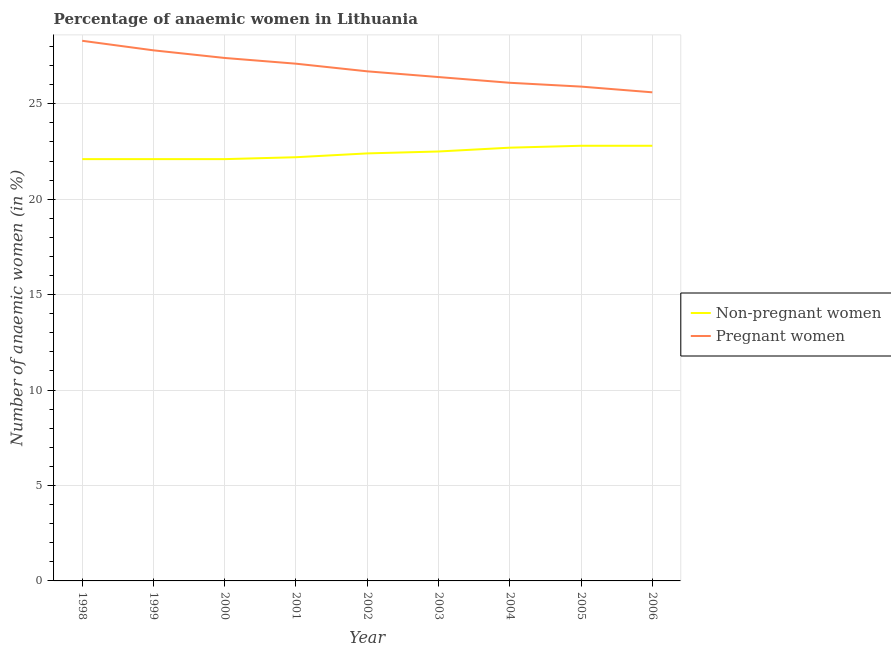How many different coloured lines are there?
Keep it short and to the point. 2. Is the number of lines equal to the number of legend labels?
Give a very brief answer. Yes. What is the percentage of non-pregnant anaemic women in 2002?
Provide a succinct answer. 22.4. Across all years, what is the maximum percentage of non-pregnant anaemic women?
Your response must be concise. 22.8. Across all years, what is the minimum percentage of pregnant anaemic women?
Your answer should be very brief. 25.6. In which year was the percentage of pregnant anaemic women maximum?
Your response must be concise. 1998. What is the total percentage of pregnant anaemic women in the graph?
Keep it short and to the point. 241.3. What is the difference between the percentage of pregnant anaemic women in 2003 and that in 2005?
Offer a very short reply. 0.5. What is the difference between the percentage of pregnant anaemic women in 2002 and the percentage of non-pregnant anaemic women in 2001?
Ensure brevity in your answer.  4.5. What is the average percentage of pregnant anaemic women per year?
Your answer should be very brief. 26.81. In the year 2003, what is the difference between the percentage of pregnant anaemic women and percentage of non-pregnant anaemic women?
Make the answer very short. 3.9. What is the ratio of the percentage of non-pregnant anaemic women in 1998 to that in 2002?
Your answer should be very brief. 0.99. Is the difference between the percentage of pregnant anaemic women in 1999 and 2005 greater than the difference between the percentage of non-pregnant anaemic women in 1999 and 2005?
Provide a short and direct response. Yes. What is the difference between the highest and the second highest percentage of pregnant anaemic women?
Your answer should be very brief. 0.5. What is the difference between the highest and the lowest percentage of non-pregnant anaemic women?
Ensure brevity in your answer.  0.7. Is the percentage of pregnant anaemic women strictly greater than the percentage of non-pregnant anaemic women over the years?
Make the answer very short. Yes. Is the percentage of non-pregnant anaemic women strictly less than the percentage of pregnant anaemic women over the years?
Offer a terse response. Yes. How many years are there in the graph?
Offer a very short reply. 9. Does the graph contain any zero values?
Keep it short and to the point. No. Does the graph contain grids?
Ensure brevity in your answer.  Yes. How are the legend labels stacked?
Provide a succinct answer. Vertical. What is the title of the graph?
Your response must be concise. Percentage of anaemic women in Lithuania. Does "US$" appear as one of the legend labels in the graph?
Provide a short and direct response. No. What is the label or title of the X-axis?
Give a very brief answer. Year. What is the label or title of the Y-axis?
Ensure brevity in your answer.  Number of anaemic women (in %). What is the Number of anaemic women (in %) in Non-pregnant women in 1998?
Offer a very short reply. 22.1. What is the Number of anaemic women (in %) of Pregnant women in 1998?
Keep it short and to the point. 28.3. What is the Number of anaemic women (in %) of Non-pregnant women in 1999?
Provide a short and direct response. 22.1. What is the Number of anaemic women (in %) in Pregnant women in 1999?
Provide a short and direct response. 27.8. What is the Number of anaemic women (in %) of Non-pregnant women in 2000?
Offer a terse response. 22.1. What is the Number of anaemic women (in %) in Pregnant women in 2000?
Provide a short and direct response. 27.4. What is the Number of anaemic women (in %) in Pregnant women in 2001?
Offer a very short reply. 27.1. What is the Number of anaemic women (in %) of Non-pregnant women in 2002?
Ensure brevity in your answer.  22.4. What is the Number of anaemic women (in %) in Pregnant women in 2002?
Your response must be concise. 26.7. What is the Number of anaemic women (in %) in Non-pregnant women in 2003?
Give a very brief answer. 22.5. What is the Number of anaemic women (in %) of Pregnant women in 2003?
Ensure brevity in your answer.  26.4. What is the Number of anaemic women (in %) in Non-pregnant women in 2004?
Your answer should be very brief. 22.7. What is the Number of anaemic women (in %) of Pregnant women in 2004?
Provide a succinct answer. 26.1. What is the Number of anaemic women (in %) in Non-pregnant women in 2005?
Provide a succinct answer. 22.8. What is the Number of anaemic women (in %) in Pregnant women in 2005?
Your answer should be very brief. 25.9. What is the Number of anaemic women (in %) of Non-pregnant women in 2006?
Your answer should be compact. 22.8. What is the Number of anaemic women (in %) in Pregnant women in 2006?
Keep it short and to the point. 25.6. Across all years, what is the maximum Number of anaemic women (in %) in Non-pregnant women?
Offer a very short reply. 22.8. Across all years, what is the maximum Number of anaemic women (in %) in Pregnant women?
Your answer should be very brief. 28.3. Across all years, what is the minimum Number of anaemic women (in %) in Non-pregnant women?
Keep it short and to the point. 22.1. Across all years, what is the minimum Number of anaemic women (in %) in Pregnant women?
Offer a terse response. 25.6. What is the total Number of anaemic women (in %) in Non-pregnant women in the graph?
Ensure brevity in your answer.  201.7. What is the total Number of anaemic women (in %) in Pregnant women in the graph?
Ensure brevity in your answer.  241.3. What is the difference between the Number of anaemic women (in %) in Non-pregnant women in 1998 and that in 2001?
Offer a very short reply. -0.1. What is the difference between the Number of anaemic women (in %) in Non-pregnant women in 1998 and that in 2002?
Your response must be concise. -0.3. What is the difference between the Number of anaemic women (in %) in Non-pregnant women in 1998 and that in 2003?
Keep it short and to the point. -0.4. What is the difference between the Number of anaemic women (in %) of Pregnant women in 1998 and that in 2003?
Offer a terse response. 1.9. What is the difference between the Number of anaemic women (in %) in Non-pregnant women in 1998 and that in 2004?
Offer a terse response. -0.6. What is the difference between the Number of anaemic women (in %) of Pregnant women in 1998 and that in 2004?
Your response must be concise. 2.2. What is the difference between the Number of anaemic women (in %) of Non-pregnant women in 1998 and that in 2005?
Make the answer very short. -0.7. What is the difference between the Number of anaemic women (in %) of Pregnant women in 1999 and that in 2000?
Your response must be concise. 0.4. What is the difference between the Number of anaemic women (in %) in Non-pregnant women in 1999 and that in 2001?
Give a very brief answer. -0.1. What is the difference between the Number of anaemic women (in %) in Non-pregnant women in 1999 and that in 2002?
Offer a very short reply. -0.3. What is the difference between the Number of anaemic women (in %) in Pregnant women in 1999 and that in 2004?
Your answer should be compact. 1.7. What is the difference between the Number of anaemic women (in %) of Pregnant women in 1999 and that in 2005?
Offer a terse response. 1.9. What is the difference between the Number of anaemic women (in %) of Pregnant women in 1999 and that in 2006?
Your response must be concise. 2.2. What is the difference between the Number of anaemic women (in %) of Non-pregnant women in 2000 and that in 2001?
Make the answer very short. -0.1. What is the difference between the Number of anaemic women (in %) in Non-pregnant women in 2000 and that in 2003?
Offer a very short reply. -0.4. What is the difference between the Number of anaemic women (in %) in Pregnant women in 2000 and that in 2003?
Offer a very short reply. 1. What is the difference between the Number of anaemic women (in %) of Pregnant women in 2000 and that in 2004?
Give a very brief answer. 1.3. What is the difference between the Number of anaemic women (in %) in Non-pregnant women in 2000 and that in 2005?
Keep it short and to the point. -0.7. What is the difference between the Number of anaemic women (in %) in Pregnant women in 2000 and that in 2006?
Your response must be concise. 1.8. What is the difference between the Number of anaemic women (in %) in Non-pregnant women in 2001 and that in 2002?
Provide a succinct answer. -0.2. What is the difference between the Number of anaemic women (in %) of Non-pregnant women in 2001 and that in 2003?
Provide a succinct answer. -0.3. What is the difference between the Number of anaemic women (in %) of Pregnant women in 2001 and that in 2003?
Ensure brevity in your answer.  0.7. What is the difference between the Number of anaemic women (in %) in Pregnant women in 2001 and that in 2004?
Offer a very short reply. 1. What is the difference between the Number of anaemic women (in %) in Pregnant women in 2001 and that in 2005?
Offer a very short reply. 1.2. What is the difference between the Number of anaemic women (in %) of Pregnant women in 2002 and that in 2003?
Provide a short and direct response. 0.3. What is the difference between the Number of anaemic women (in %) of Non-pregnant women in 2003 and that in 2006?
Give a very brief answer. -0.3. What is the difference between the Number of anaemic women (in %) of Pregnant women in 2003 and that in 2006?
Provide a succinct answer. 0.8. What is the difference between the Number of anaemic women (in %) in Non-pregnant women in 2004 and that in 2006?
Your answer should be compact. -0.1. What is the difference between the Number of anaemic women (in %) in Non-pregnant women in 2005 and that in 2006?
Your response must be concise. 0. What is the difference between the Number of anaemic women (in %) in Pregnant women in 2005 and that in 2006?
Offer a very short reply. 0.3. What is the difference between the Number of anaemic women (in %) in Non-pregnant women in 1998 and the Number of anaemic women (in %) in Pregnant women in 1999?
Ensure brevity in your answer.  -5.7. What is the difference between the Number of anaemic women (in %) of Non-pregnant women in 1998 and the Number of anaemic women (in %) of Pregnant women in 2001?
Provide a short and direct response. -5. What is the difference between the Number of anaemic women (in %) in Non-pregnant women in 1998 and the Number of anaemic women (in %) in Pregnant women in 2002?
Your answer should be very brief. -4.6. What is the difference between the Number of anaemic women (in %) of Non-pregnant women in 1998 and the Number of anaemic women (in %) of Pregnant women in 2003?
Make the answer very short. -4.3. What is the difference between the Number of anaemic women (in %) in Non-pregnant women in 1998 and the Number of anaemic women (in %) in Pregnant women in 2004?
Give a very brief answer. -4. What is the difference between the Number of anaemic women (in %) of Non-pregnant women in 1998 and the Number of anaemic women (in %) of Pregnant women in 2005?
Your answer should be compact. -3.8. What is the difference between the Number of anaemic women (in %) of Non-pregnant women in 1999 and the Number of anaemic women (in %) of Pregnant women in 2005?
Make the answer very short. -3.8. What is the difference between the Number of anaemic women (in %) in Non-pregnant women in 2000 and the Number of anaemic women (in %) in Pregnant women in 2001?
Offer a very short reply. -5. What is the difference between the Number of anaemic women (in %) in Non-pregnant women in 2000 and the Number of anaemic women (in %) in Pregnant women in 2002?
Your answer should be very brief. -4.6. What is the difference between the Number of anaemic women (in %) in Non-pregnant women in 2000 and the Number of anaemic women (in %) in Pregnant women in 2003?
Keep it short and to the point. -4.3. What is the difference between the Number of anaemic women (in %) of Non-pregnant women in 2000 and the Number of anaemic women (in %) of Pregnant women in 2006?
Provide a short and direct response. -3.5. What is the difference between the Number of anaemic women (in %) of Non-pregnant women in 2001 and the Number of anaemic women (in %) of Pregnant women in 2002?
Offer a terse response. -4.5. What is the difference between the Number of anaemic women (in %) in Non-pregnant women in 2001 and the Number of anaemic women (in %) in Pregnant women in 2003?
Offer a terse response. -4.2. What is the difference between the Number of anaemic women (in %) in Non-pregnant women in 2001 and the Number of anaemic women (in %) in Pregnant women in 2004?
Ensure brevity in your answer.  -3.9. What is the difference between the Number of anaemic women (in %) in Non-pregnant women in 2001 and the Number of anaemic women (in %) in Pregnant women in 2006?
Offer a very short reply. -3.4. What is the difference between the Number of anaemic women (in %) in Non-pregnant women in 2002 and the Number of anaemic women (in %) in Pregnant women in 2004?
Offer a very short reply. -3.7. What is the difference between the Number of anaemic women (in %) in Non-pregnant women in 2002 and the Number of anaemic women (in %) in Pregnant women in 2005?
Make the answer very short. -3.5. What is the difference between the Number of anaemic women (in %) of Non-pregnant women in 2002 and the Number of anaemic women (in %) of Pregnant women in 2006?
Ensure brevity in your answer.  -3.2. What is the difference between the Number of anaemic women (in %) in Non-pregnant women in 2003 and the Number of anaemic women (in %) in Pregnant women in 2006?
Ensure brevity in your answer.  -3.1. What is the difference between the Number of anaemic women (in %) in Non-pregnant women in 2004 and the Number of anaemic women (in %) in Pregnant women in 2006?
Provide a succinct answer. -2.9. What is the average Number of anaemic women (in %) of Non-pregnant women per year?
Your answer should be compact. 22.41. What is the average Number of anaemic women (in %) of Pregnant women per year?
Keep it short and to the point. 26.81. In the year 1999, what is the difference between the Number of anaemic women (in %) of Non-pregnant women and Number of anaemic women (in %) of Pregnant women?
Offer a very short reply. -5.7. In the year 2000, what is the difference between the Number of anaemic women (in %) of Non-pregnant women and Number of anaemic women (in %) of Pregnant women?
Provide a short and direct response. -5.3. In the year 2002, what is the difference between the Number of anaemic women (in %) of Non-pregnant women and Number of anaemic women (in %) of Pregnant women?
Your answer should be compact. -4.3. In the year 2003, what is the difference between the Number of anaemic women (in %) in Non-pregnant women and Number of anaemic women (in %) in Pregnant women?
Ensure brevity in your answer.  -3.9. In the year 2004, what is the difference between the Number of anaemic women (in %) in Non-pregnant women and Number of anaemic women (in %) in Pregnant women?
Your answer should be very brief. -3.4. In the year 2006, what is the difference between the Number of anaemic women (in %) in Non-pregnant women and Number of anaemic women (in %) in Pregnant women?
Keep it short and to the point. -2.8. What is the ratio of the Number of anaemic women (in %) of Pregnant women in 1998 to that in 1999?
Provide a short and direct response. 1.02. What is the ratio of the Number of anaemic women (in %) in Non-pregnant women in 1998 to that in 2000?
Offer a terse response. 1. What is the ratio of the Number of anaemic women (in %) of Pregnant women in 1998 to that in 2000?
Your response must be concise. 1.03. What is the ratio of the Number of anaemic women (in %) of Non-pregnant women in 1998 to that in 2001?
Provide a succinct answer. 1. What is the ratio of the Number of anaemic women (in %) of Pregnant women in 1998 to that in 2001?
Your answer should be compact. 1.04. What is the ratio of the Number of anaemic women (in %) in Non-pregnant women in 1998 to that in 2002?
Provide a short and direct response. 0.99. What is the ratio of the Number of anaemic women (in %) in Pregnant women in 1998 to that in 2002?
Provide a short and direct response. 1.06. What is the ratio of the Number of anaemic women (in %) in Non-pregnant women in 1998 to that in 2003?
Give a very brief answer. 0.98. What is the ratio of the Number of anaemic women (in %) of Pregnant women in 1998 to that in 2003?
Your response must be concise. 1.07. What is the ratio of the Number of anaemic women (in %) of Non-pregnant women in 1998 to that in 2004?
Give a very brief answer. 0.97. What is the ratio of the Number of anaemic women (in %) of Pregnant women in 1998 to that in 2004?
Offer a very short reply. 1.08. What is the ratio of the Number of anaemic women (in %) in Non-pregnant women in 1998 to that in 2005?
Give a very brief answer. 0.97. What is the ratio of the Number of anaemic women (in %) of Pregnant women in 1998 to that in 2005?
Provide a succinct answer. 1.09. What is the ratio of the Number of anaemic women (in %) of Non-pregnant women in 1998 to that in 2006?
Offer a very short reply. 0.97. What is the ratio of the Number of anaemic women (in %) of Pregnant women in 1998 to that in 2006?
Your response must be concise. 1.11. What is the ratio of the Number of anaemic women (in %) of Pregnant women in 1999 to that in 2000?
Provide a succinct answer. 1.01. What is the ratio of the Number of anaemic women (in %) of Non-pregnant women in 1999 to that in 2001?
Make the answer very short. 1. What is the ratio of the Number of anaemic women (in %) of Pregnant women in 1999 to that in 2001?
Provide a short and direct response. 1.03. What is the ratio of the Number of anaemic women (in %) of Non-pregnant women in 1999 to that in 2002?
Keep it short and to the point. 0.99. What is the ratio of the Number of anaemic women (in %) of Pregnant women in 1999 to that in 2002?
Your response must be concise. 1.04. What is the ratio of the Number of anaemic women (in %) of Non-pregnant women in 1999 to that in 2003?
Your answer should be compact. 0.98. What is the ratio of the Number of anaemic women (in %) of Pregnant women in 1999 to that in 2003?
Offer a terse response. 1.05. What is the ratio of the Number of anaemic women (in %) in Non-pregnant women in 1999 to that in 2004?
Keep it short and to the point. 0.97. What is the ratio of the Number of anaemic women (in %) in Pregnant women in 1999 to that in 2004?
Ensure brevity in your answer.  1.07. What is the ratio of the Number of anaemic women (in %) in Non-pregnant women in 1999 to that in 2005?
Make the answer very short. 0.97. What is the ratio of the Number of anaemic women (in %) of Pregnant women in 1999 to that in 2005?
Make the answer very short. 1.07. What is the ratio of the Number of anaemic women (in %) in Non-pregnant women in 1999 to that in 2006?
Provide a short and direct response. 0.97. What is the ratio of the Number of anaemic women (in %) of Pregnant women in 1999 to that in 2006?
Your answer should be very brief. 1.09. What is the ratio of the Number of anaemic women (in %) in Non-pregnant women in 2000 to that in 2001?
Keep it short and to the point. 1. What is the ratio of the Number of anaemic women (in %) in Pregnant women in 2000 to that in 2001?
Provide a succinct answer. 1.01. What is the ratio of the Number of anaemic women (in %) in Non-pregnant women in 2000 to that in 2002?
Offer a very short reply. 0.99. What is the ratio of the Number of anaemic women (in %) of Pregnant women in 2000 to that in 2002?
Give a very brief answer. 1.03. What is the ratio of the Number of anaemic women (in %) of Non-pregnant women in 2000 to that in 2003?
Your answer should be compact. 0.98. What is the ratio of the Number of anaemic women (in %) in Pregnant women in 2000 to that in 2003?
Provide a short and direct response. 1.04. What is the ratio of the Number of anaemic women (in %) in Non-pregnant women in 2000 to that in 2004?
Your answer should be compact. 0.97. What is the ratio of the Number of anaemic women (in %) of Pregnant women in 2000 to that in 2004?
Your response must be concise. 1.05. What is the ratio of the Number of anaemic women (in %) in Non-pregnant women in 2000 to that in 2005?
Give a very brief answer. 0.97. What is the ratio of the Number of anaemic women (in %) of Pregnant women in 2000 to that in 2005?
Provide a succinct answer. 1.06. What is the ratio of the Number of anaemic women (in %) in Non-pregnant women in 2000 to that in 2006?
Provide a short and direct response. 0.97. What is the ratio of the Number of anaemic women (in %) in Pregnant women in 2000 to that in 2006?
Your answer should be compact. 1.07. What is the ratio of the Number of anaemic women (in %) of Pregnant women in 2001 to that in 2002?
Your response must be concise. 1.01. What is the ratio of the Number of anaemic women (in %) of Non-pregnant women in 2001 to that in 2003?
Offer a very short reply. 0.99. What is the ratio of the Number of anaemic women (in %) of Pregnant women in 2001 to that in 2003?
Make the answer very short. 1.03. What is the ratio of the Number of anaemic women (in %) in Non-pregnant women in 2001 to that in 2004?
Keep it short and to the point. 0.98. What is the ratio of the Number of anaemic women (in %) in Pregnant women in 2001 to that in 2004?
Provide a succinct answer. 1.04. What is the ratio of the Number of anaemic women (in %) of Non-pregnant women in 2001 to that in 2005?
Make the answer very short. 0.97. What is the ratio of the Number of anaemic women (in %) of Pregnant women in 2001 to that in 2005?
Provide a succinct answer. 1.05. What is the ratio of the Number of anaemic women (in %) in Non-pregnant women in 2001 to that in 2006?
Your response must be concise. 0.97. What is the ratio of the Number of anaemic women (in %) in Pregnant women in 2001 to that in 2006?
Your answer should be compact. 1.06. What is the ratio of the Number of anaemic women (in %) of Pregnant women in 2002 to that in 2003?
Offer a terse response. 1.01. What is the ratio of the Number of anaemic women (in %) in Pregnant women in 2002 to that in 2004?
Provide a succinct answer. 1.02. What is the ratio of the Number of anaemic women (in %) of Non-pregnant women in 2002 to that in 2005?
Give a very brief answer. 0.98. What is the ratio of the Number of anaemic women (in %) of Pregnant women in 2002 to that in 2005?
Give a very brief answer. 1.03. What is the ratio of the Number of anaemic women (in %) of Non-pregnant women in 2002 to that in 2006?
Your answer should be compact. 0.98. What is the ratio of the Number of anaemic women (in %) in Pregnant women in 2002 to that in 2006?
Provide a succinct answer. 1.04. What is the ratio of the Number of anaemic women (in %) of Non-pregnant women in 2003 to that in 2004?
Offer a very short reply. 0.99. What is the ratio of the Number of anaemic women (in %) in Pregnant women in 2003 to that in 2004?
Offer a terse response. 1.01. What is the ratio of the Number of anaemic women (in %) of Non-pregnant women in 2003 to that in 2005?
Make the answer very short. 0.99. What is the ratio of the Number of anaemic women (in %) in Pregnant women in 2003 to that in 2005?
Make the answer very short. 1.02. What is the ratio of the Number of anaemic women (in %) in Non-pregnant women in 2003 to that in 2006?
Offer a very short reply. 0.99. What is the ratio of the Number of anaemic women (in %) in Pregnant women in 2003 to that in 2006?
Your answer should be compact. 1.03. What is the ratio of the Number of anaemic women (in %) in Non-pregnant women in 2004 to that in 2005?
Your answer should be compact. 1. What is the ratio of the Number of anaemic women (in %) of Pregnant women in 2004 to that in 2005?
Make the answer very short. 1.01. What is the ratio of the Number of anaemic women (in %) in Non-pregnant women in 2004 to that in 2006?
Keep it short and to the point. 1. What is the ratio of the Number of anaemic women (in %) of Pregnant women in 2004 to that in 2006?
Your answer should be compact. 1.02. What is the ratio of the Number of anaemic women (in %) of Pregnant women in 2005 to that in 2006?
Provide a succinct answer. 1.01. What is the difference between the highest and the lowest Number of anaemic women (in %) in Non-pregnant women?
Give a very brief answer. 0.7. 